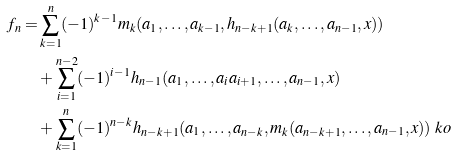<formula> <loc_0><loc_0><loc_500><loc_500>f _ { n } = & \sum _ { k = 1 } ^ { n } ( - 1 ) ^ { k - 1 } m _ { k } ( a _ { 1 } , \dots , a _ { k - 1 } , h _ { n - k + 1 } ( a _ { k } , \dots , a _ { n - 1 } , x ) ) \\ & + \sum _ { i = 1 } ^ { n - 2 } ( - 1 ) ^ { i - 1 } h _ { n - 1 } ( a _ { 1 } , \dots , a _ { i } a _ { i + 1 } , \dots , a _ { n - 1 } , x ) \\ & + \sum _ { k = 1 } ^ { n } ( - 1 ) ^ { n - k } h _ { n - k + 1 } ( a _ { 1 } , \dots , a _ { n - k } , m _ { k } ( a _ { n - k + 1 } , \dots , a _ { n - 1 } , x ) ) \ k o</formula> 